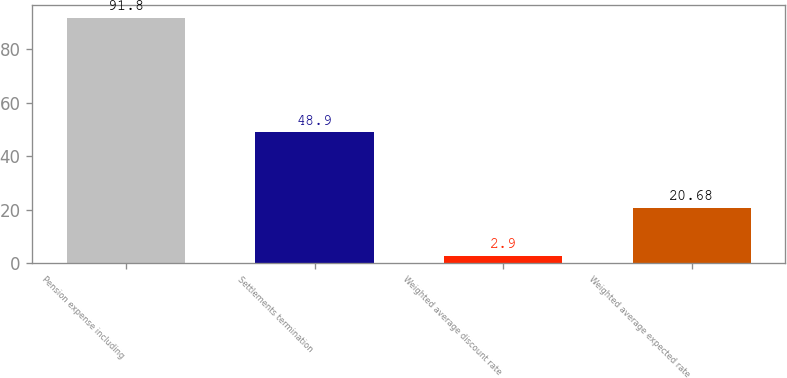Convert chart to OTSL. <chart><loc_0><loc_0><loc_500><loc_500><bar_chart><fcel>Pension expense including<fcel>Settlements termination<fcel>Weighted average discount rate<fcel>Weighted average expected rate<nl><fcel>91.8<fcel>48.9<fcel>2.9<fcel>20.68<nl></chart> 